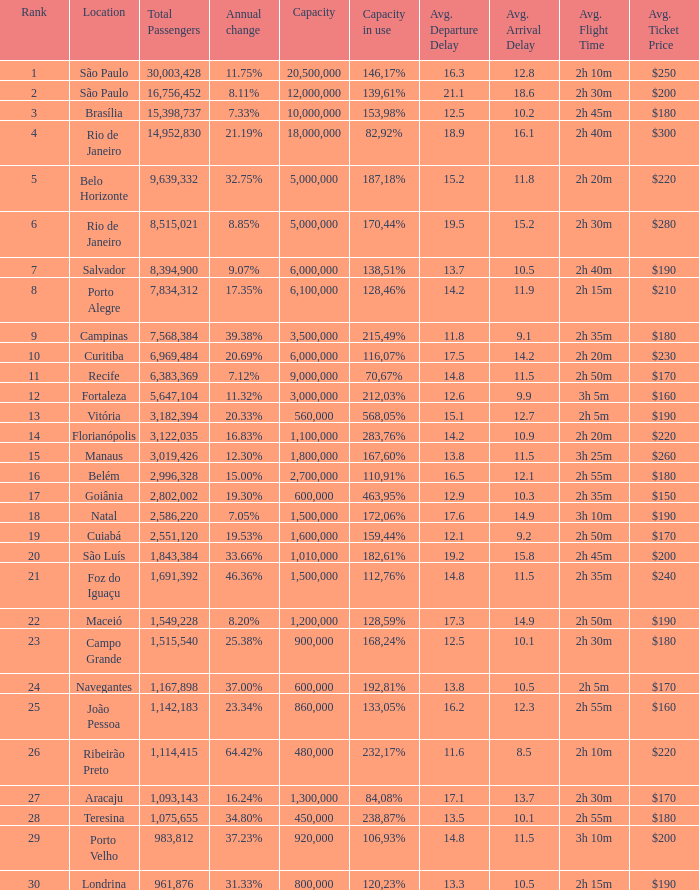Which location has a capacity that has a rank of 23? 168,24%. 